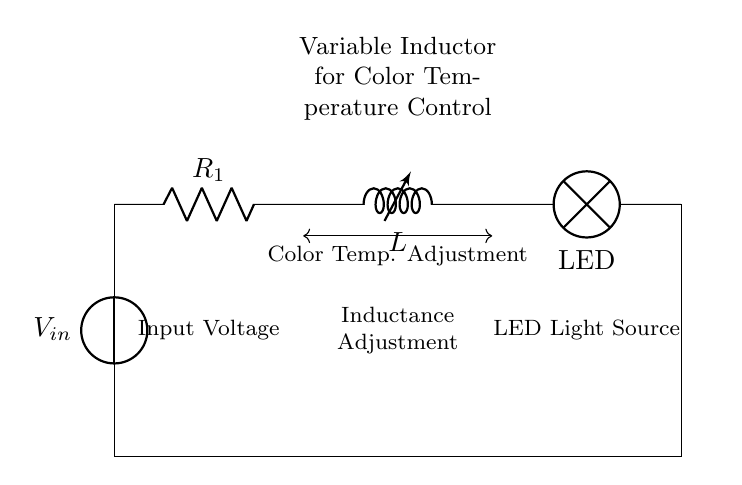What is the type of lamp used in the circuit? The circuit diagram indicates that an LED is used as the light source. This is identified at the rightmost side of the diagram, where it is labeled as LED.
Answer: LED What component is used for color temperature adjustment? The component labeled as a variable inductor is specifically used for color temperature adjustment. It is located between the resistor and the LED in the circuit.
Answer: Variable inductor How many main circuit components are present in the diagram? The circuit consists of three main components: a resistor, a variable inductor, and an LED. These are the key elements depicted in the diagram.
Answer: Three What function does the resistor serve in the circuit? The resistor provides a limited current flow, ensuring that the LED and the variable inductor operate within safe parameters. It is essential for controlling the overall behavior of the circuit.
Answer: Current limiting What is the purpose of the variable inductor in this application? The primary purpose of the variable inductor is to adjust the inductance, which in turn modifies the color temperature of the light emitted by the LED. This allows for dynamic changes in the lighting condition during artwork photography.
Answer: Color temperature adjustment How does the input voltage relate to the operation of the circuit? The input voltage is the energy source for the circuit, and it flows from the voltage source through the resistor and into the variable inductor, powering the LED to emit light. This is critical for the operation of the entire circuit.
Answer: Power supply 